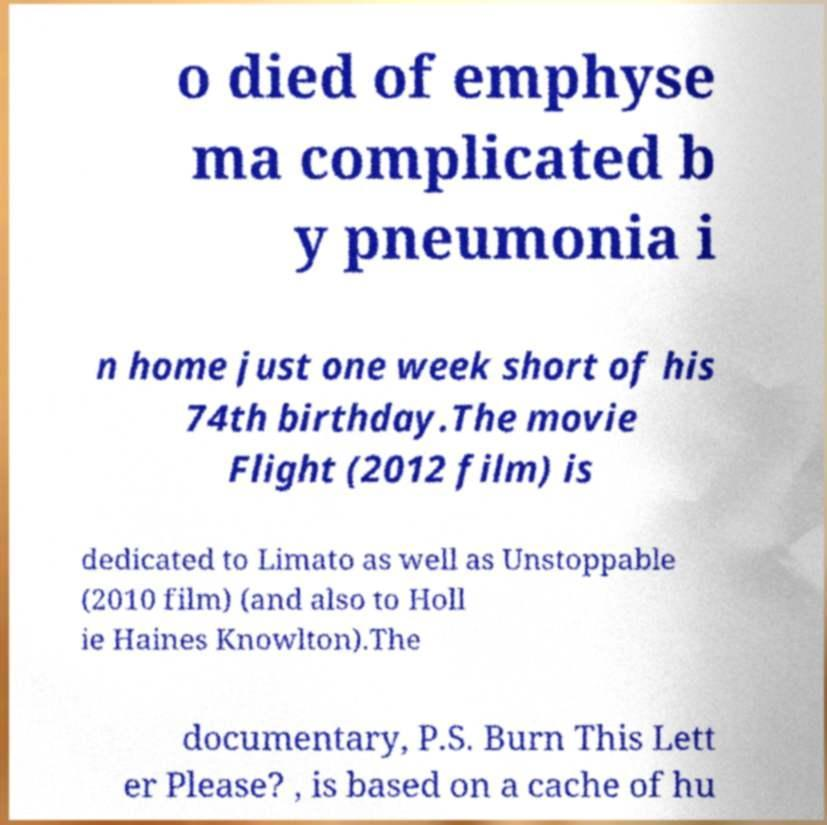For documentation purposes, I need the text within this image transcribed. Could you provide that? o died of emphyse ma complicated b y pneumonia i n home just one week short of his 74th birthday.The movie Flight (2012 film) is dedicated to Limato as well as Unstoppable (2010 film) (and also to Holl ie Haines Knowlton).The documentary, P.S. Burn This Lett er Please? , is based on a cache of hu 